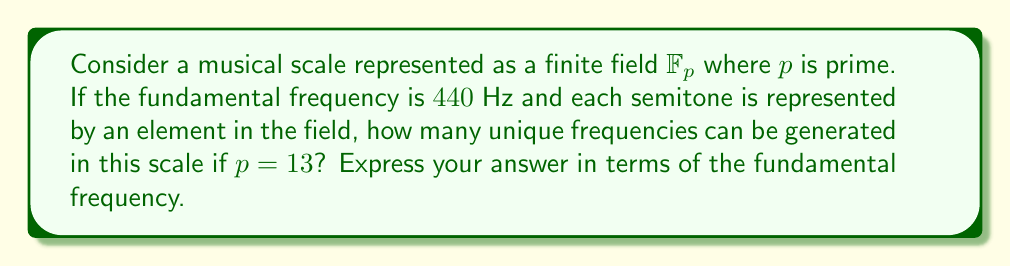Could you help me with this problem? Let's approach this step-by-step:

1) In field theory, we're treating our musical scale as a finite field $\mathbb{F}_{13}$, where 13 represents the number of semitones in an octave (including the octave itself).

2) Each element in the field represents a semitone. In Western music, the frequency ratio between two adjacent semitones is $2^{1/12}$.

3) Let's denote our fundamental frequency (440 Hz) as $f_0$. Then, the frequency of the $n$-th semitone above the fundamental can be expressed as:

   $$f_n = f_0 \cdot (2^{1/12})^n$$

4) In our field $\mathbb{F}_{13}$, $n$ can take values from 0 to 12. Therefore, the frequencies we can generate are:

   $$f_0, f_0 \cdot 2^{1/12}, f_0 \cdot 2^{2/12}, ..., f_0 \cdot 2^{12/12} = 2f_0$$

5) Each of these frequencies corresponds to a unique element in our field.

6) Therefore, the number of unique frequencies is equal to the number of elements in our field, which is 13.

7) We can express these 13 frequencies in terms of the fundamental frequency $f_0$ as:

   $$\{f_0 \cdot 2^{n/12} \mid n = 0, 1, 2, ..., 12\}$$
Answer: 13 frequencies: $\{f_0 \cdot 2^{n/12} \mid n = 0, 1, 2, ..., 12\}$ 